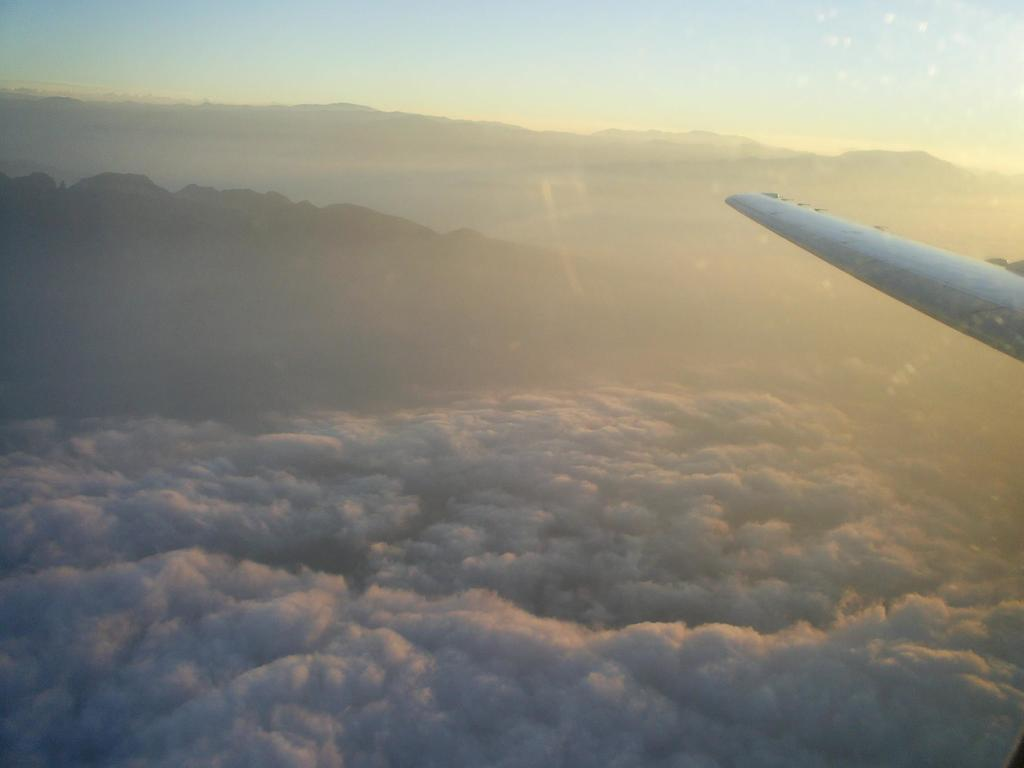What is the perspective of the image? The image is a view from a plane. What type of geographical feature can be seen in the image? There are mountains visible in the image. What else is visible in the sky besides the mountains? There are clouds visible in the image. What is the income of the person who caused the reaction in the image? There is no person or reaction present in the image, as it is a view from a plane featuring mountains and clouds. 